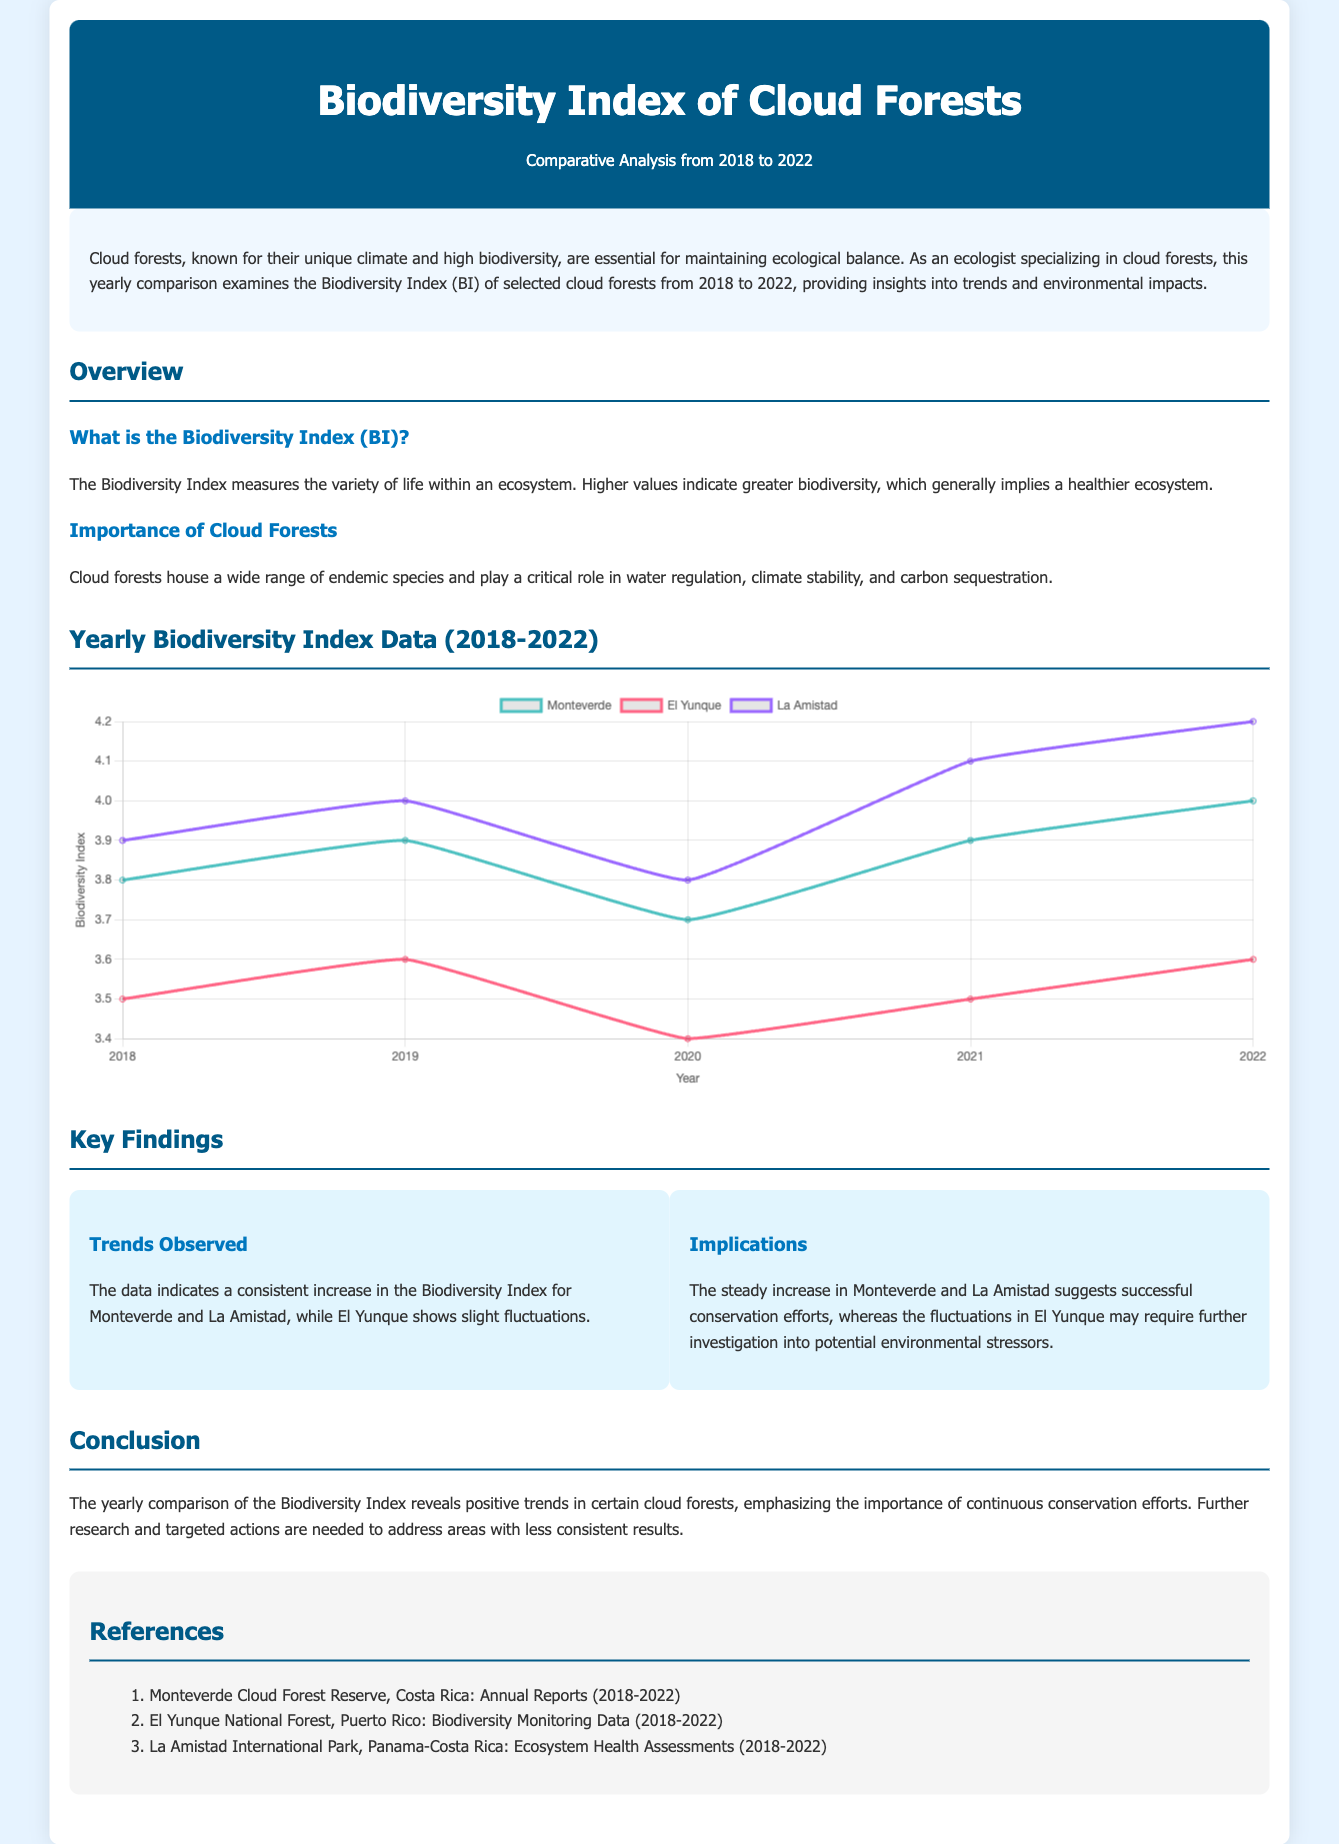What is the title of the document? The title is prominently displayed in the header section of the document.
Answer: Biodiversity Index of Cloud Forests: A Yearly Comparison What years are compared in the document? The document specifically analyzes a range of years for comparison, mentioned in both the title and sections.
Answer: 2018 to 2022 Which cloud forest showed a steady increase in the Biodiversity Index? The text provides specific trends observed over the years for each forest studied.
Answer: Monteverde and La Amistad What was the Biodiversity Index for La Amistad in 2022? The data presented in the chart provides the Biodiversity Index for each forest and year.
Answer: 4.2 What does a higher Biodiversity Index indicate? The document explains the meaning of the Biodiversity Index under the Overview section.
Answer: Greater biodiversity What might require further investigation according to the findings? Key findings highlight the need for further research in specific areas based on trends observed.
Answer: El Yunque How many datasets are represented in the chart? Counting the objects in the datasets shown visually in the chart helps answer this.
Answer: Three What is the significance of cloud forests mentioned in the document? The document outlines the critical roles that cloud forests play, which is highlighted in a specific section.
Answer: Water regulation, climate stability, and carbon sequestration 